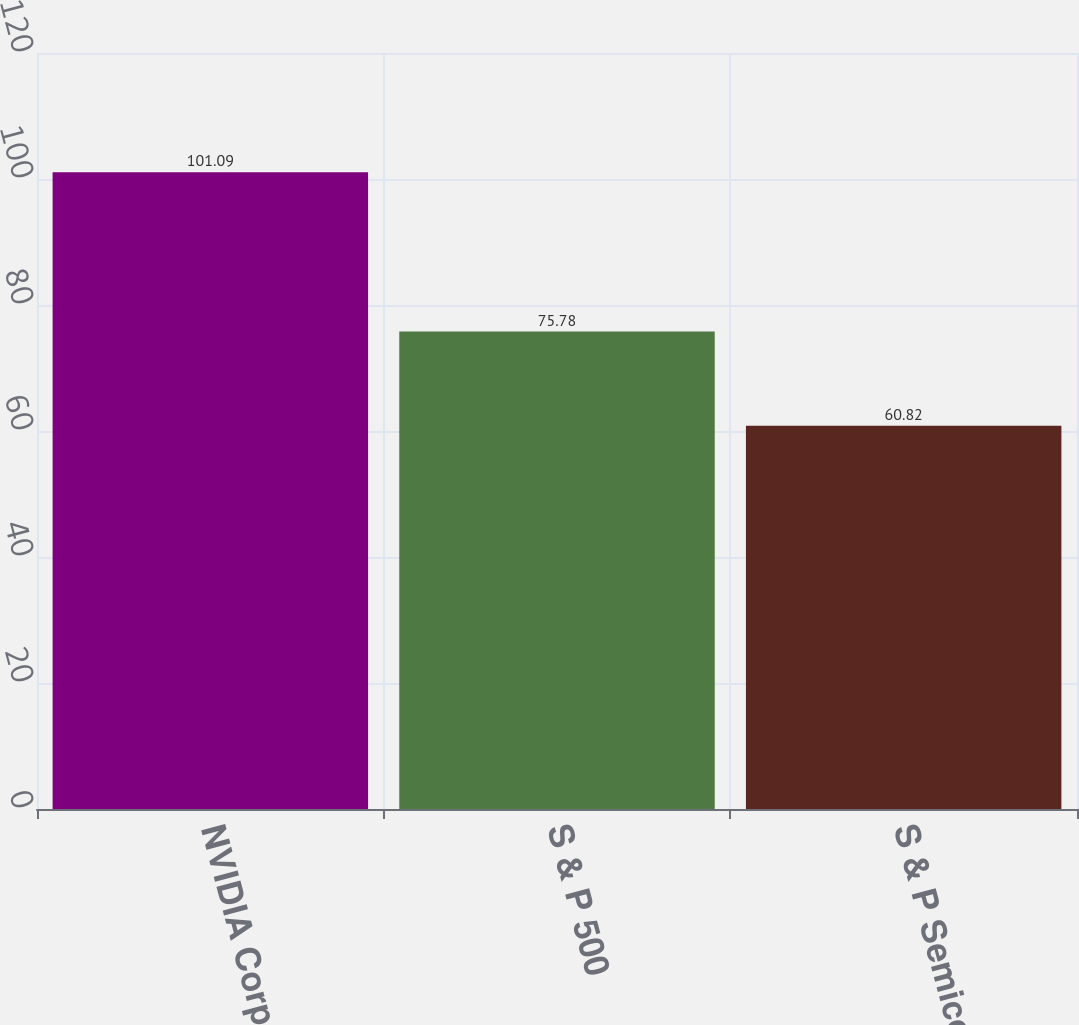Convert chart. <chart><loc_0><loc_0><loc_500><loc_500><bar_chart><fcel>NVIDIA Corporation<fcel>S & P 500<fcel>S & P Semiconductors<nl><fcel>101.09<fcel>75.78<fcel>60.82<nl></chart> 